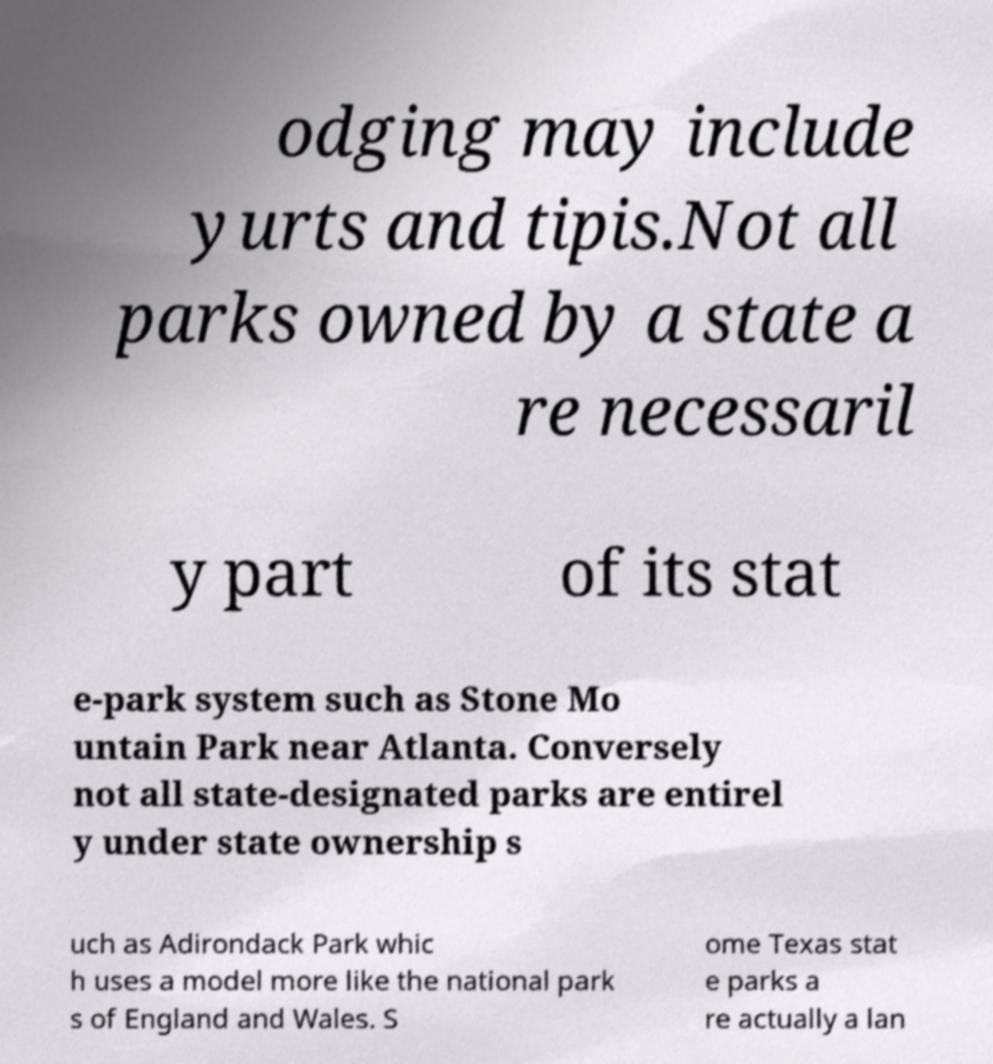Can you read and provide the text displayed in the image?This photo seems to have some interesting text. Can you extract and type it out for me? odging may include yurts and tipis.Not all parks owned by a state a re necessaril y part of its stat e-park system such as Stone Mo untain Park near Atlanta. Conversely not all state-designated parks are entirel y under state ownership s uch as Adirondack Park whic h uses a model more like the national park s of England and Wales. S ome Texas stat e parks a re actually a lan 